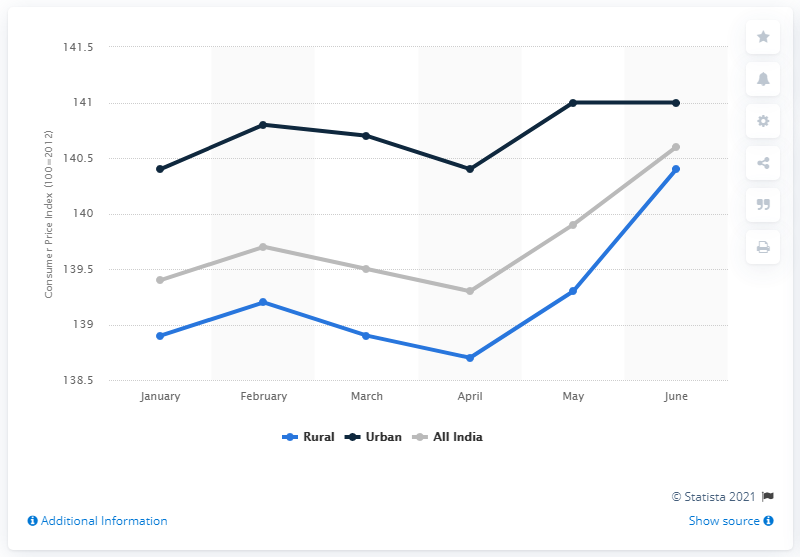Highlight a few significant elements in this photo. The Consumer Price Index for spices across India in June 2019 was 140.6. 